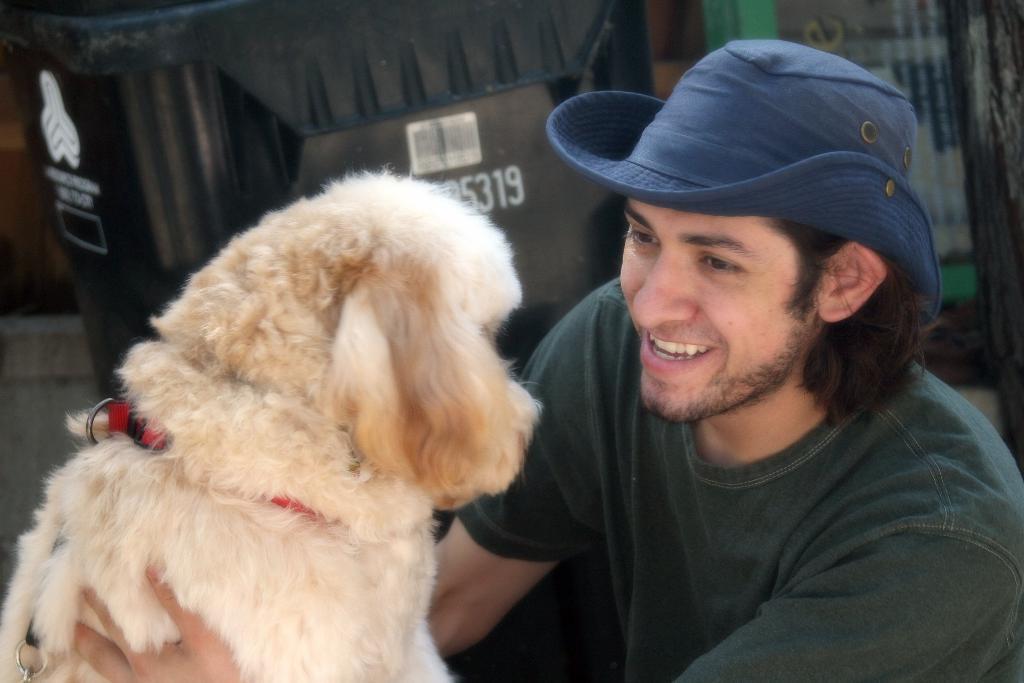Please provide a concise description of this image. In the picture we can see a man smiling and catching a dog, he is wearing a hat which is blue in colour. In the background we can see a television which is turned around. 